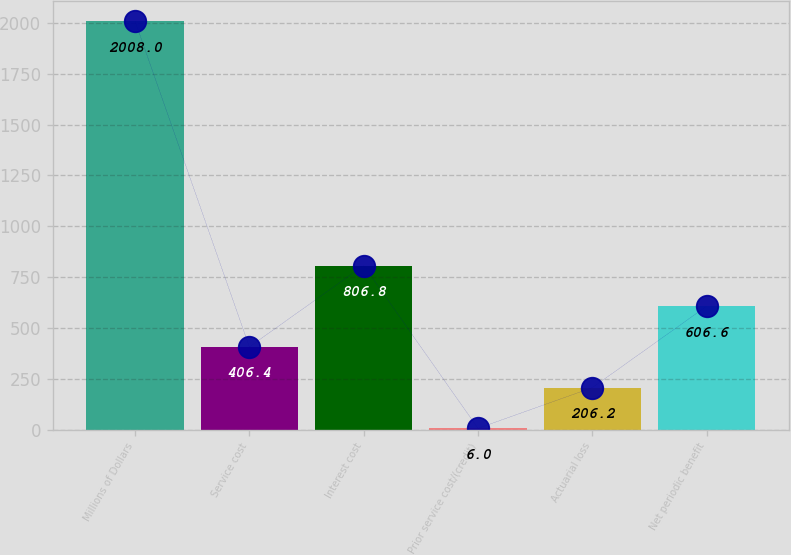<chart> <loc_0><loc_0><loc_500><loc_500><bar_chart><fcel>Millions of Dollars<fcel>Service cost<fcel>Interest cost<fcel>Prior service cost/(credit)<fcel>Actuarial loss<fcel>Net periodic benefit<nl><fcel>2008<fcel>406.4<fcel>806.8<fcel>6<fcel>206.2<fcel>606.6<nl></chart> 